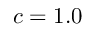Convert formula to latex. <formula><loc_0><loc_0><loc_500><loc_500>c = 1 . 0</formula> 